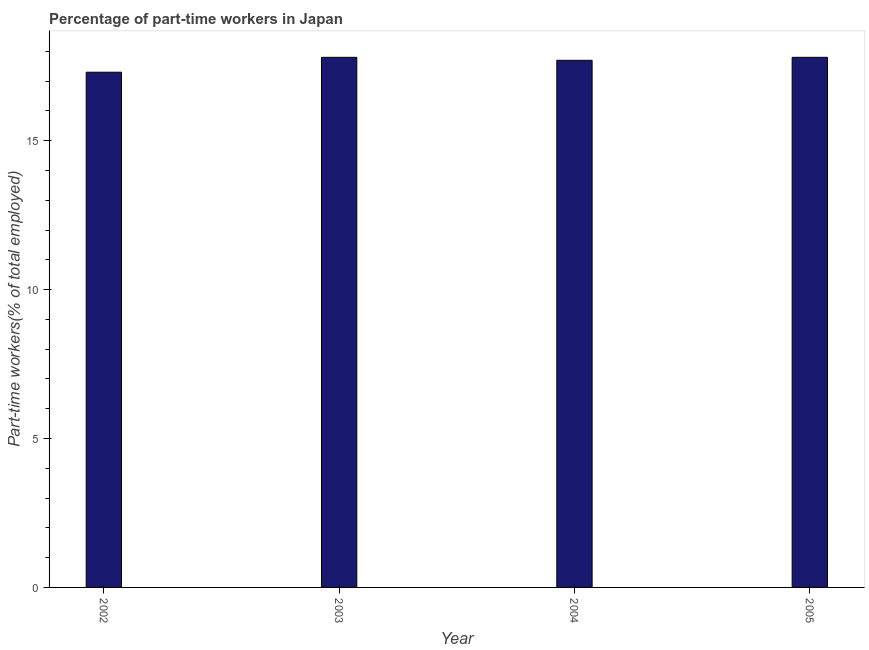Does the graph contain any zero values?
Ensure brevity in your answer.  No. Does the graph contain grids?
Ensure brevity in your answer.  No. What is the title of the graph?
Offer a terse response. Percentage of part-time workers in Japan. What is the label or title of the X-axis?
Provide a short and direct response. Year. What is the label or title of the Y-axis?
Ensure brevity in your answer.  Part-time workers(% of total employed). What is the percentage of part-time workers in 2002?
Offer a very short reply. 17.3. Across all years, what is the maximum percentage of part-time workers?
Your answer should be compact. 17.8. Across all years, what is the minimum percentage of part-time workers?
Your answer should be very brief. 17.3. In which year was the percentage of part-time workers minimum?
Your answer should be very brief. 2002. What is the sum of the percentage of part-time workers?
Your response must be concise. 70.6. What is the difference between the percentage of part-time workers in 2003 and 2005?
Ensure brevity in your answer.  0. What is the average percentage of part-time workers per year?
Provide a short and direct response. 17.65. What is the median percentage of part-time workers?
Give a very brief answer. 17.75. In how many years, is the percentage of part-time workers greater than 8 %?
Keep it short and to the point. 4. Do a majority of the years between 2002 and 2005 (inclusive) have percentage of part-time workers greater than 13 %?
Provide a succinct answer. Yes. Is the percentage of part-time workers in 2002 less than that in 2005?
Your answer should be very brief. Yes. What is the difference between the highest and the second highest percentage of part-time workers?
Keep it short and to the point. 0. In how many years, is the percentage of part-time workers greater than the average percentage of part-time workers taken over all years?
Provide a short and direct response. 3. How many bars are there?
Provide a succinct answer. 4. What is the difference between two consecutive major ticks on the Y-axis?
Your answer should be compact. 5. Are the values on the major ticks of Y-axis written in scientific E-notation?
Provide a succinct answer. No. What is the Part-time workers(% of total employed) of 2002?
Provide a succinct answer. 17.3. What is the Part-time workers(% of total employed) in 2003?
Provide a short and direct response. 17.8. What is the Part-time workers(% of total employed) in 2004?
Provide a short and direct response. 17.7. What is the Part-time workers(% of total employed) in 2005?
Provide a short and direct response. 17.8. What is the difference between the Part-time workers(% of total employed) in 2002 and 2005?
Keep it short and to the point. -0.5. What is the difference between the Part-time workers(% of total employed) in 2003 and 2004?
Offer a terse response. 0.1. What is the ratio of the Part-time workers(% of total employed) in 2002 to that in 2004?
Provide a succinct answer. 0.98. What is the ratio of the Part-time workers(% of total employed) in 2002 to that in 2005?
Offer a very short reply. 0.97. What is the ratio of the Part-time workers(% of total employed) in 2003 to that in 2004?
Ensure brevity in your answer.  1.01. 